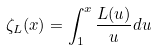Convert formula to latex. <formula><loc_0><loc_0><loc_500><loc_500>\zeta _ { L } ( x ) = \int _ { 1 } ^ { x } \frac { L ( u ) } { u } d u</formula> 